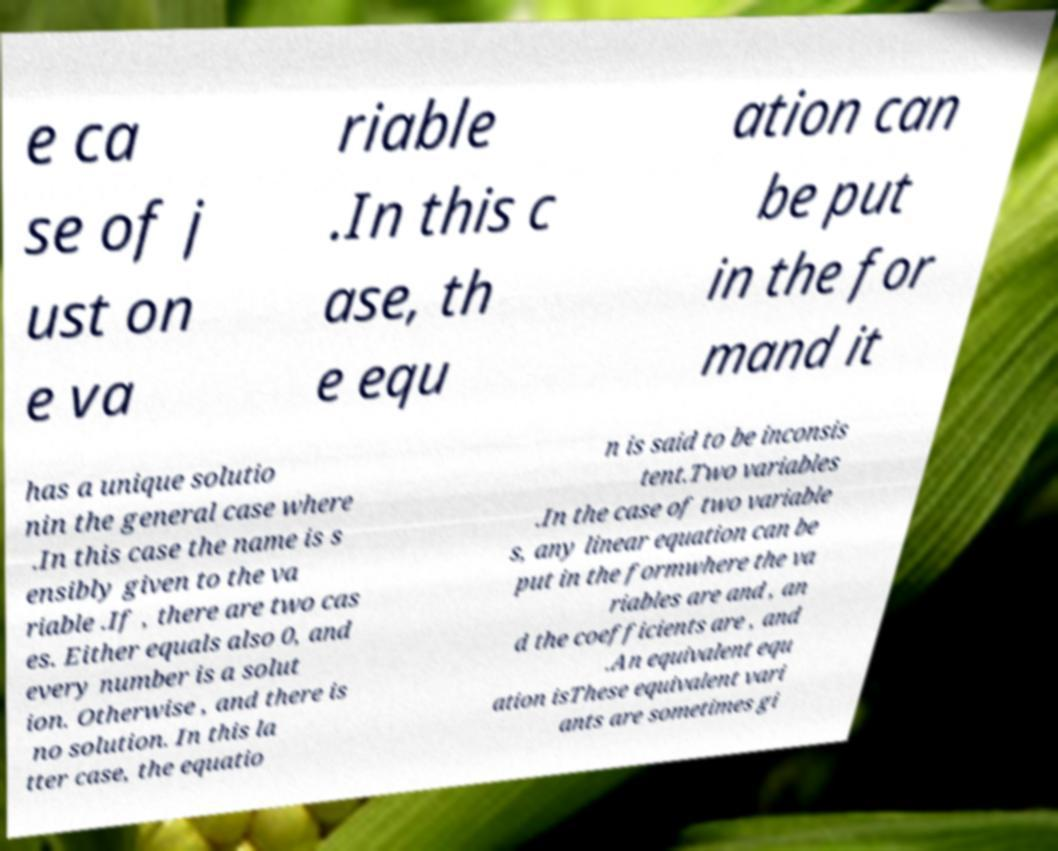Can you read and provide the text displayed in the image?This photo seems to have some interesting text. Can you extract and type it out for me? e ca se of j ust on e va riable .In this c ase, th e equ ation can be put in the for mand it has a unique solutio nin the general case where .In this case the name is s ensibly given to the va riable .If , there are two cas es. Either equals also 0, and every number is a solut ion. Otherwise , and there is no solution. In this la tter case, the equatio n is said to be inconsis tent.Two variables .In the case of two variable s, any linear equation can be put in the formwhere the va riables are and , an d the coefficients are , and .An equivalent equ ation isThese equivalent vari ants are sometimes gi 